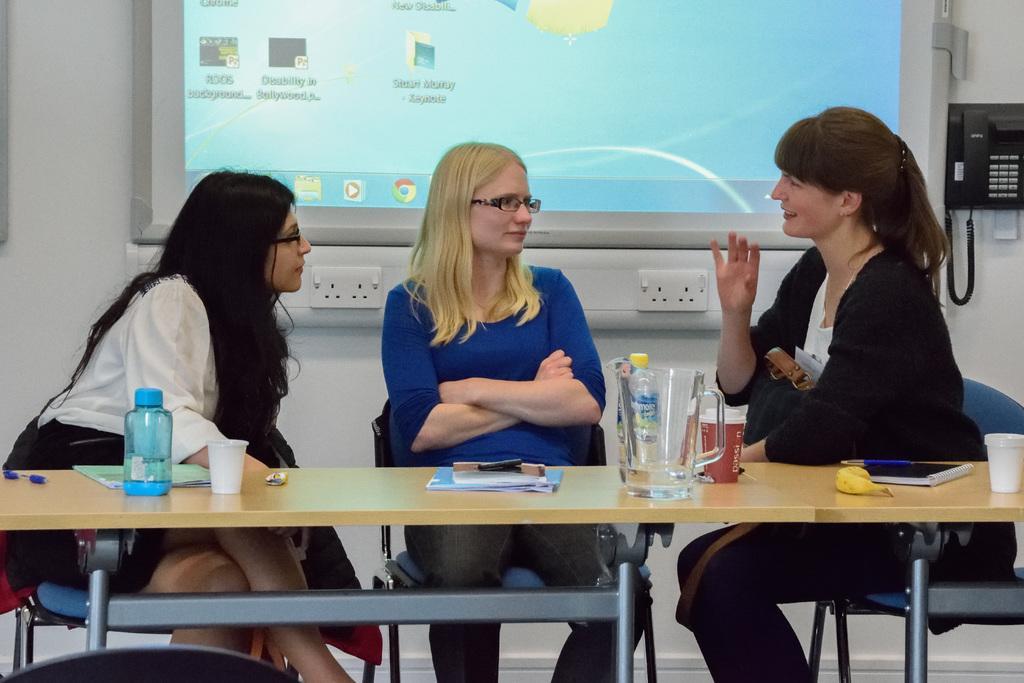Could you give a brief overview of what you see in this image? In this image i can see a back ground there is screen ,beside the screen there is a telephone and three women sitting on chair discussing. And on the right side there is a woman wearing a black color shirt, she is smiling and on the middle there is a woman wearing a blue color shirt ,she is wearing a spectacles. And on the left side there is a woman wearing a white color shirt she is wearing a spectacles. in front of them there is a table. 